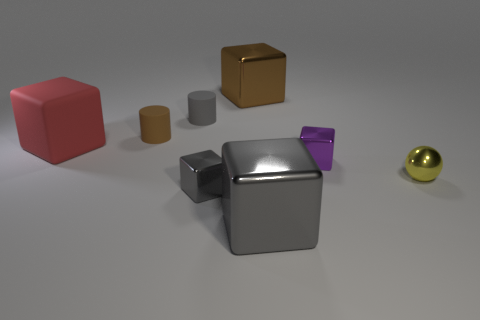Is the material of the big thing that is to the left of the brown metal object the same as the tiny gray object behind the red block?
Your answer should be compact. Yes. There is a big shiny object that is on the left side of the gray metal cube in front of the small gray object that is in front of the big red matte cube; what is its shape?
Make the answer very short. Cube. Is the number of gray shiny blocks greater than the number of blocks?
Your answer should be very brief. No. Are any large blue matte cubes visible?
Give a very brief answer. No. How many objects are rubber objects in front of the brown rubber object or tiny cylinders right of the tiny brown rubber cylinder?
Give a very brief answer. 2. Is the number of tiny gray objects less than the number of small metal things?
Your response must be concise. Yes. Are there any cylinders behind the red matte cube?
Provide a short and direct response. Yes. Does the gray cylinder have the same material as the large red object?
Offer a terse response. Yes. There is another small thing that is the same shape as the small purple object; what is its color?
Your answer should be very brief. Gray. What number of other cylinders are made of the same material as the gray cylinder?
Your answer should be compact. 1. 